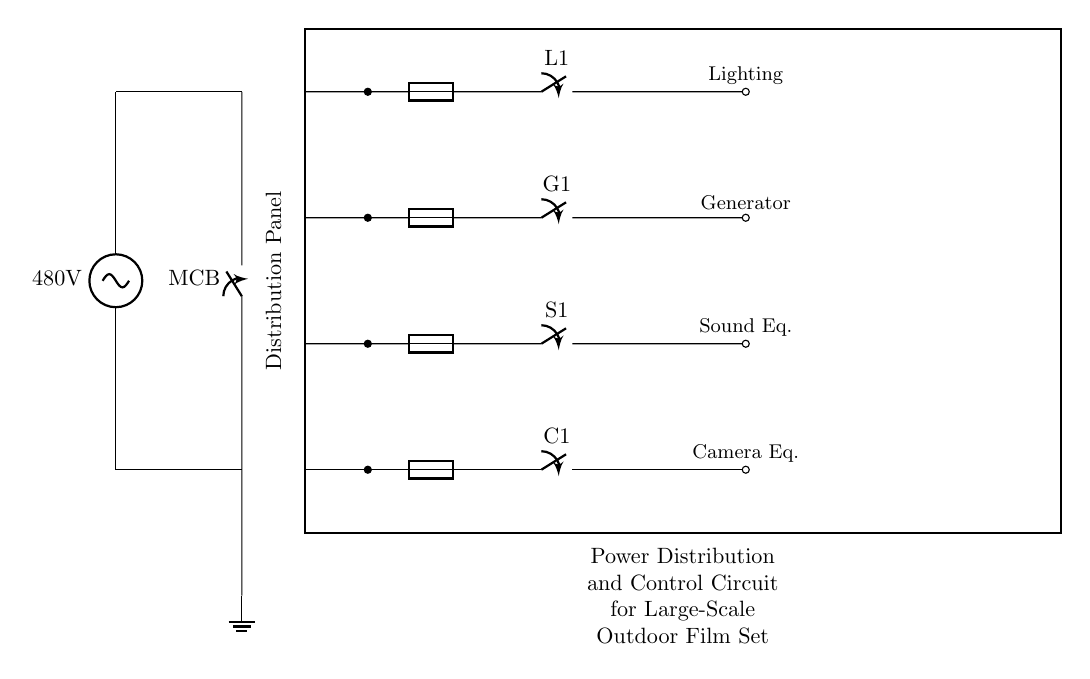What is the main voltage of the power supply? The main voltage can be found in the circuit as it is directly labeled next to the power supply component. It indicates the voltage being supplied to the system.
Answer: 480 volts What components are included in the lighting circuit? To find the components of the lighting circuit, I look for the specific path designated for lighting. This involves identifying the fuse and the closing switch connected to it according to the circuit layout.
Answer: Fuse, L1 switch How many separate circuits are present in the distribution panel? By visually scanning the connections coming out of the distribution panel, we can count the individual branches marked for different functions. Each unique path indicates a separate circuit.
Answer: Four What is the purpose of the MCB in this circuit? The MCB is placed at the beginning of the circuit. It serves the purpose of protecting the circuit from overloads and short circuits by automatically switching off in case of faults.
Answer: Overcurrent protection Which circuit is used for sound equipment? The sound equipment circuit can be identified by tracing the specific path designated for sound-related connections, which includes a fuse and a switch for that specific purpose within the overall circuit layout.
Answer: The circuit with S1 switch What connects the ground to the main circuit? To assess the grounding connection, I check for the continuity from the main circuit through to the grounding terminal to confirm how the ground is integrated within the circuit. The main connection point is specified in the diagram.
Answer: Ground connection How does the generator circuit connect to the distribution panel? An examination of the diagram shows how the generator circuit connects to the distribution panel, noting that there is a direct line from the generator branch to a dedicated terminal, which demonstrates its role in supplying power.
Answer: Through the G1 switch 